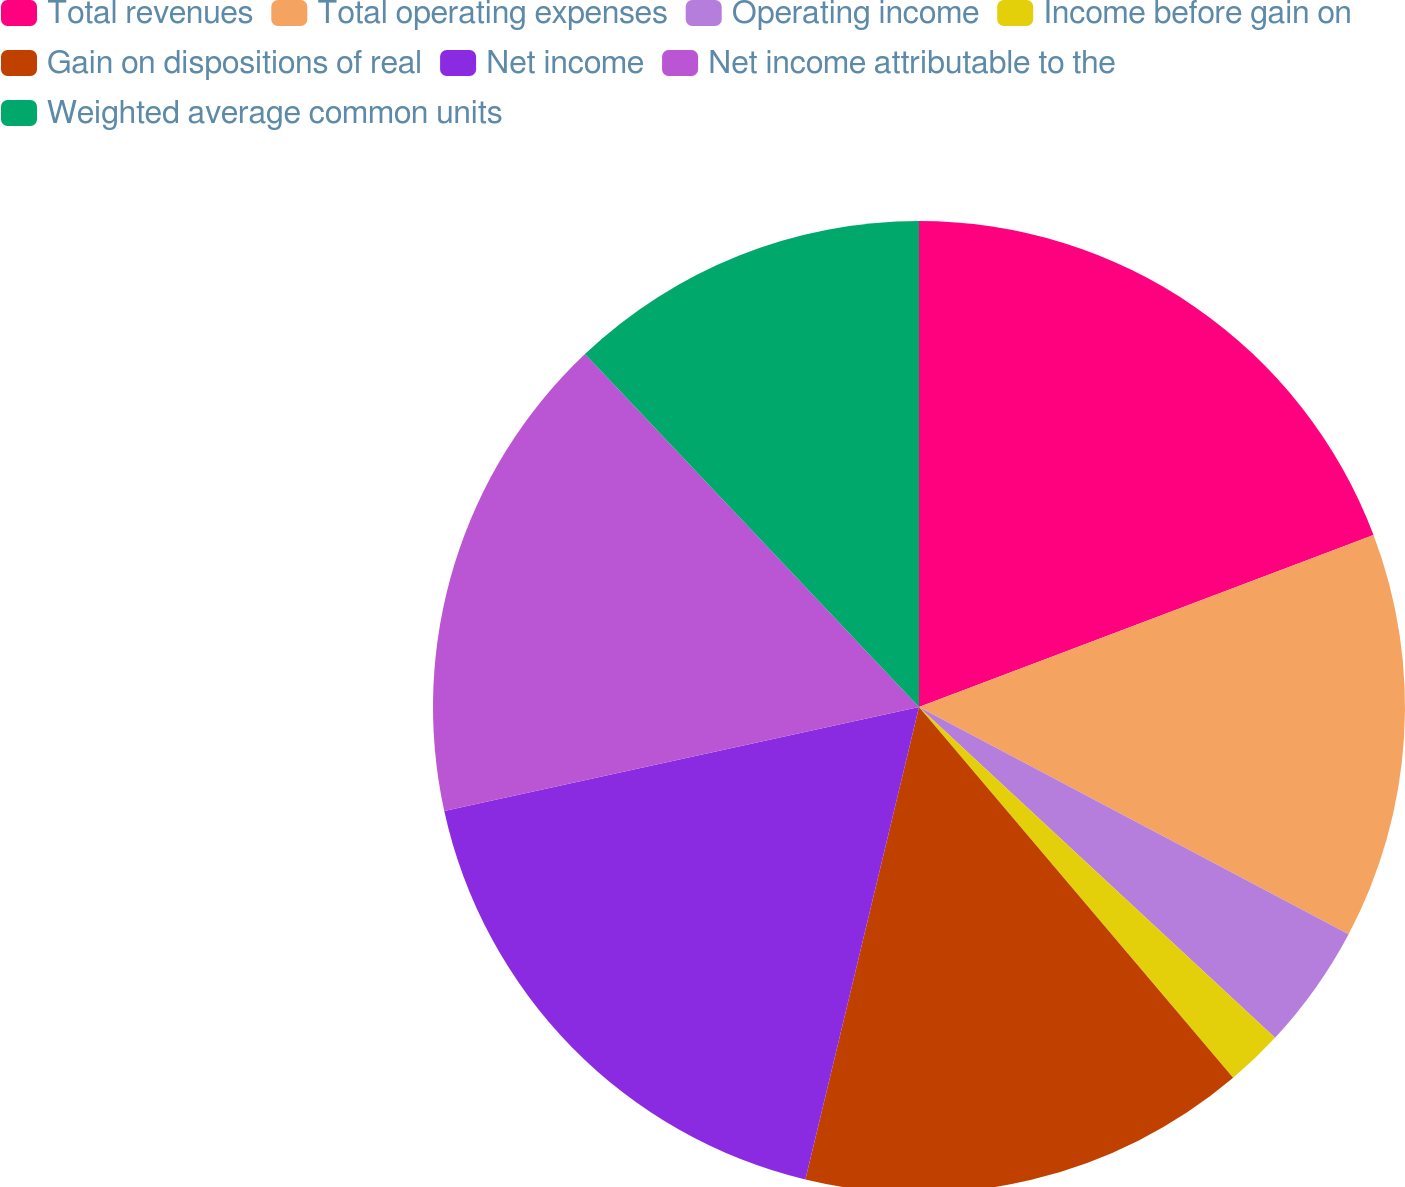<chart> <loc_0><loc_0><loc_500><loc_500><pie_chart><fcel>Total revenues<fcel>Total operating expenses<fcel>Operating income<fcel>Income before gain on<fcel>Gain on dispositions of real<fcel>Net income<fcel>Net income attributable to the<fcel>Weighted average common units<nl><fcel>19.24%<fcel>13.5%<fcel>4.17%<fcel>1.9%<fcel>14.94%<fcel>17.81%<fcel>16.37%<fcel>12.06%<nl></chart> 